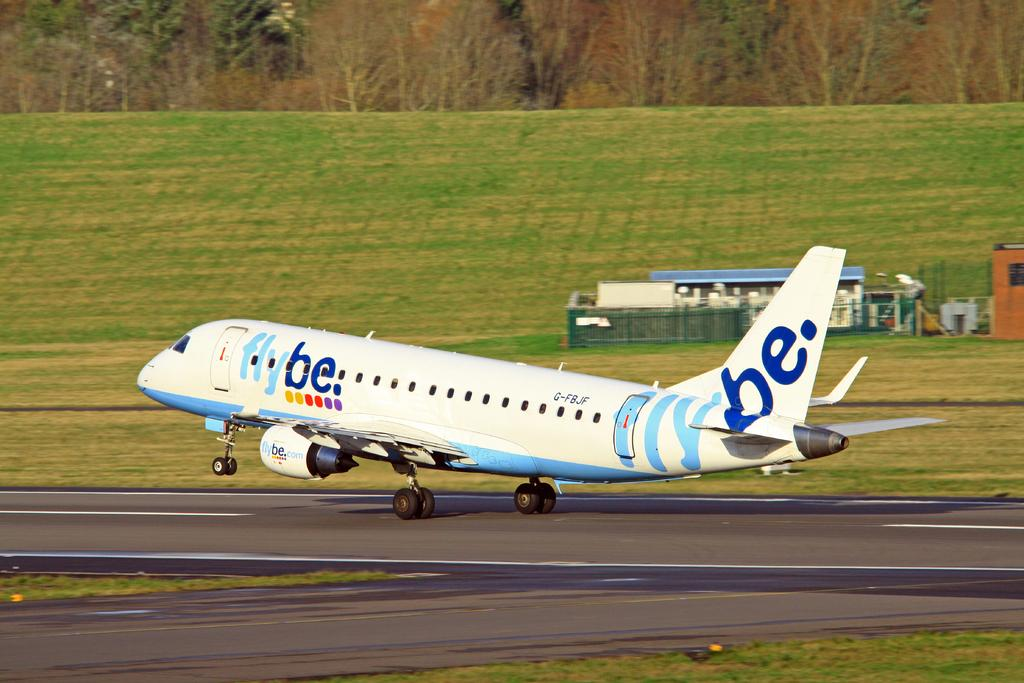<image>
Summarize the visual content of the image. a Fly BE plane about to take off from a runway 